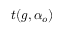<formula> <loc_0><loc_0><loc_500><loc_500>t ( g , \alpha _ { o } )</formula> 